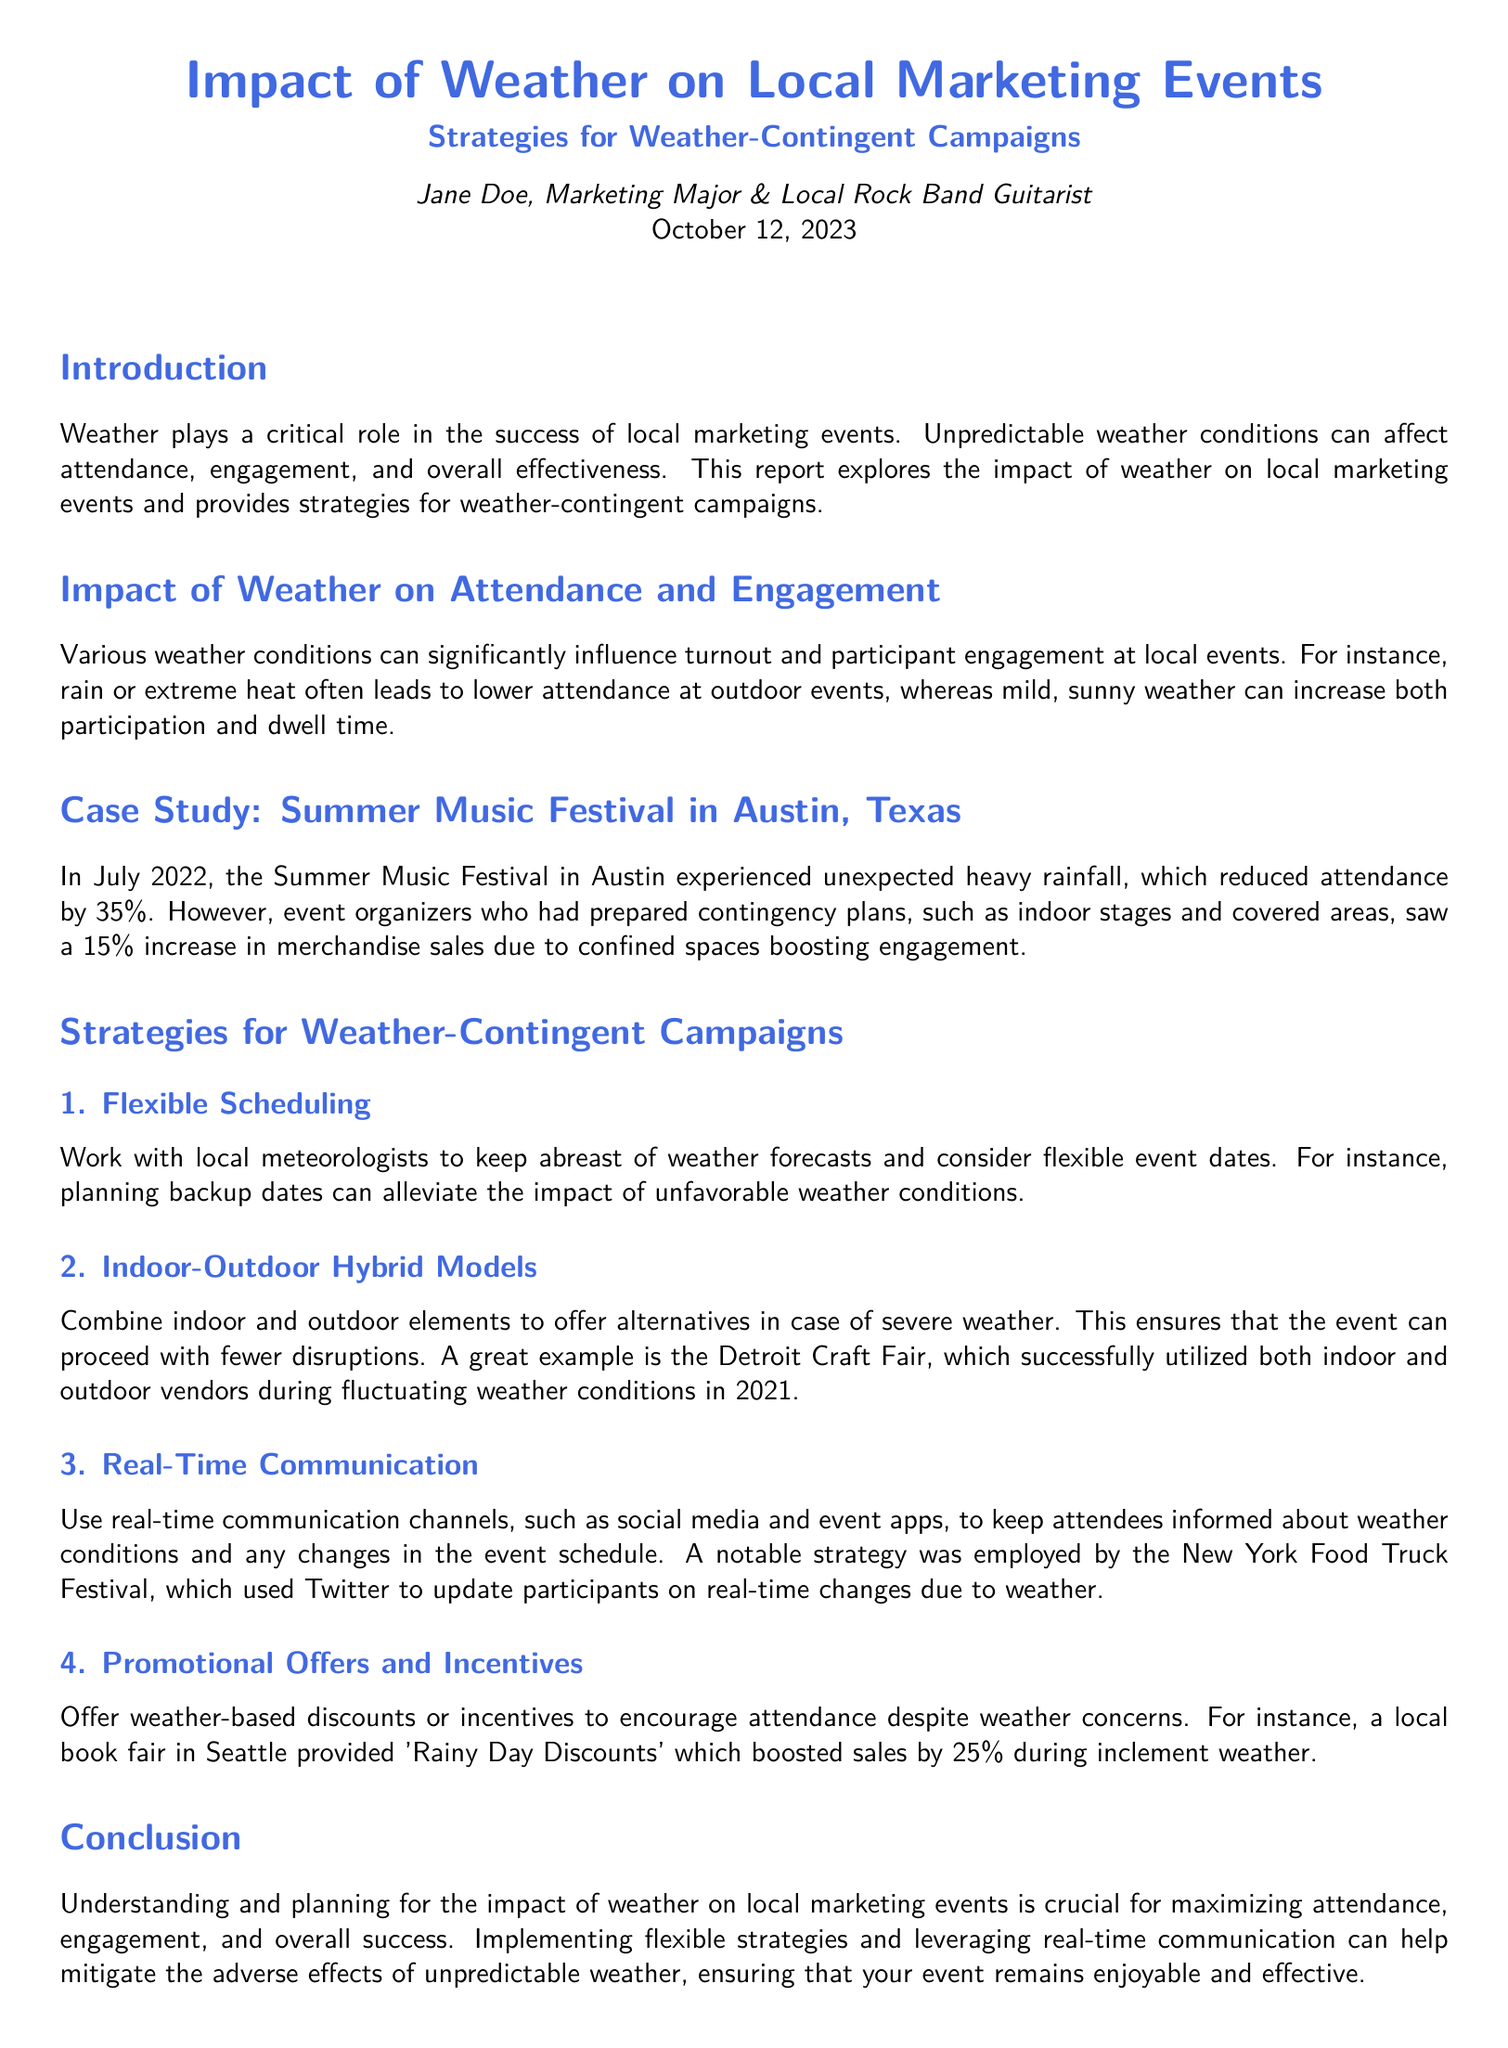What is the title of the report? The title of the report is stated in the document as "Impact of Weather on Local Marketing Events".
Answer: Impact of Weather on Local Marketing Events Who is the author of the report? The author is introduced at the beginning of the document as Jane Doe.
Answer: Jane Doe What was the percentage decrease in attendance at the Summer Music Festival due to rainfall? The document states that attendance decreased by 35% because of the rainfall.
Answer: 35% What is one strategy for handling unfavorable weather? The document lists "Flexible Scheduling" as one of the strategies for handling unfavorable weather conditions.
Answer: Flexible Scheduling Which event used real-time communication on Twitter? The document mentions the New York Food Truck Festival as the event that used Twitter for real-time updates.
Answer: New York Food Truck Festival What was created to provide weather-based discounts during inclement weather? The document references 'Rainy Day Discounts' as a promotional offer during inclement weather.
Answer: Rainy Day Discounts What type of models did the Detroit Craft Fair employ? According to the document, the Detroit Craft Fair utilized "Indoor-Outdoor Hybrid Models".
Answer: Indoor-Outdoor Hybrid Models What is a key takeaway mentioned in the conclusion? The conclusion emphasizes the importance of understanding and planning for the impact of weather on local marketing events.
Answer: Understanding and planning for the impact of weather 